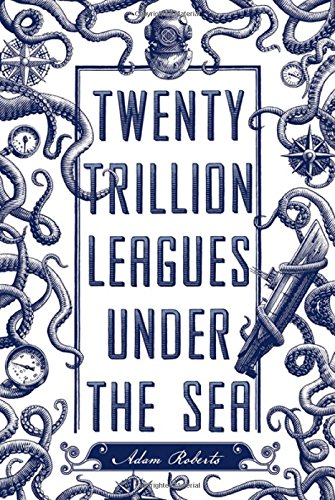What is the genre of this book? This novel can be classified under Science Fiction & Fantasy, offering readers an imaginative foray into speculative narratives and futuristic visions. 